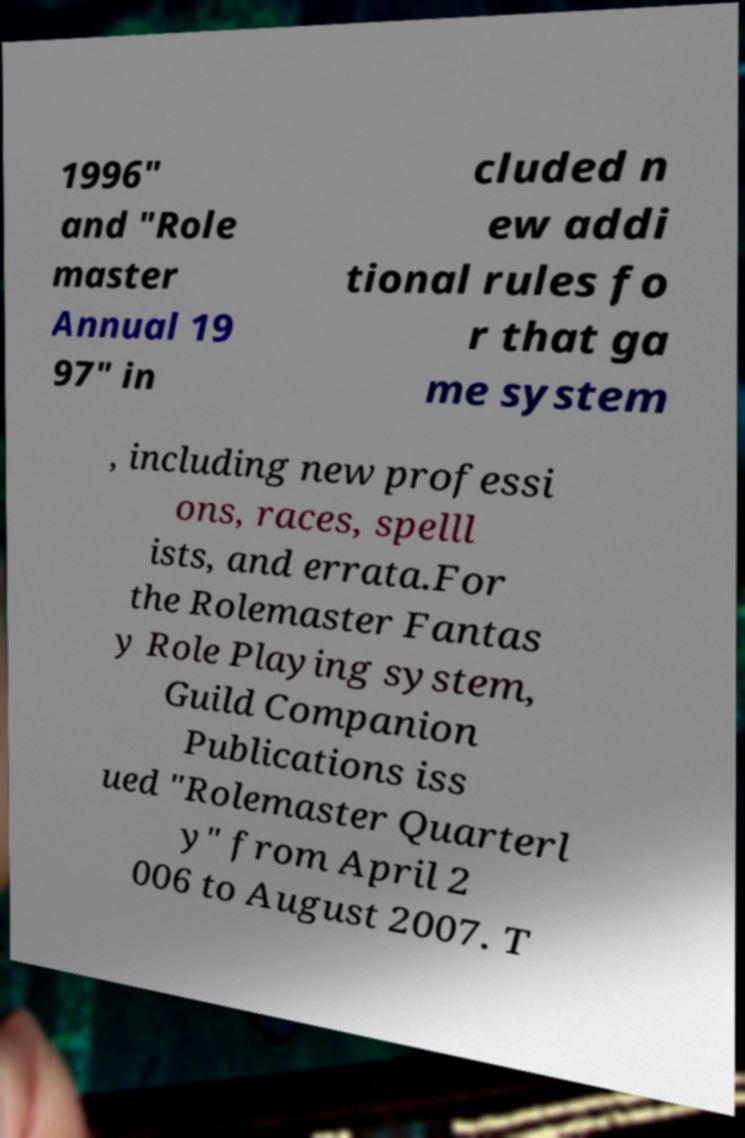Please read and relay the text visible in this image. What does it say? 1996" and "Role master Annual 19 97" in cluded n ew addi tional rules fo r that ga me system , including new professi ons, races, spelll ists, and errata.For the Rolemaster Fantas y Role Playing system, Guild Companion Publications iss ued "Rolemaster Quarterl y" from April 2 006 to August 2007. T 